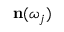<formula> <loc_0><loc_0><loc_500><loc_500>n ( \omega _ { j } )</formula> 